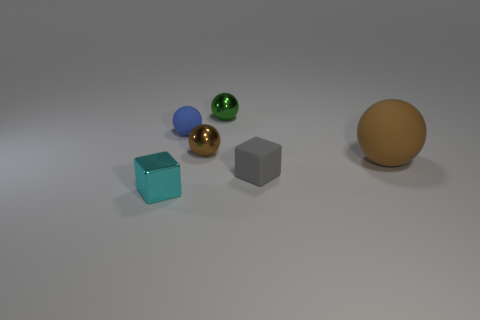What shape is the other object that is the same color as the big object? The other object sharing the same color as the big sphere is also a sphere. It appears smaller in size and has a reflective surface. 